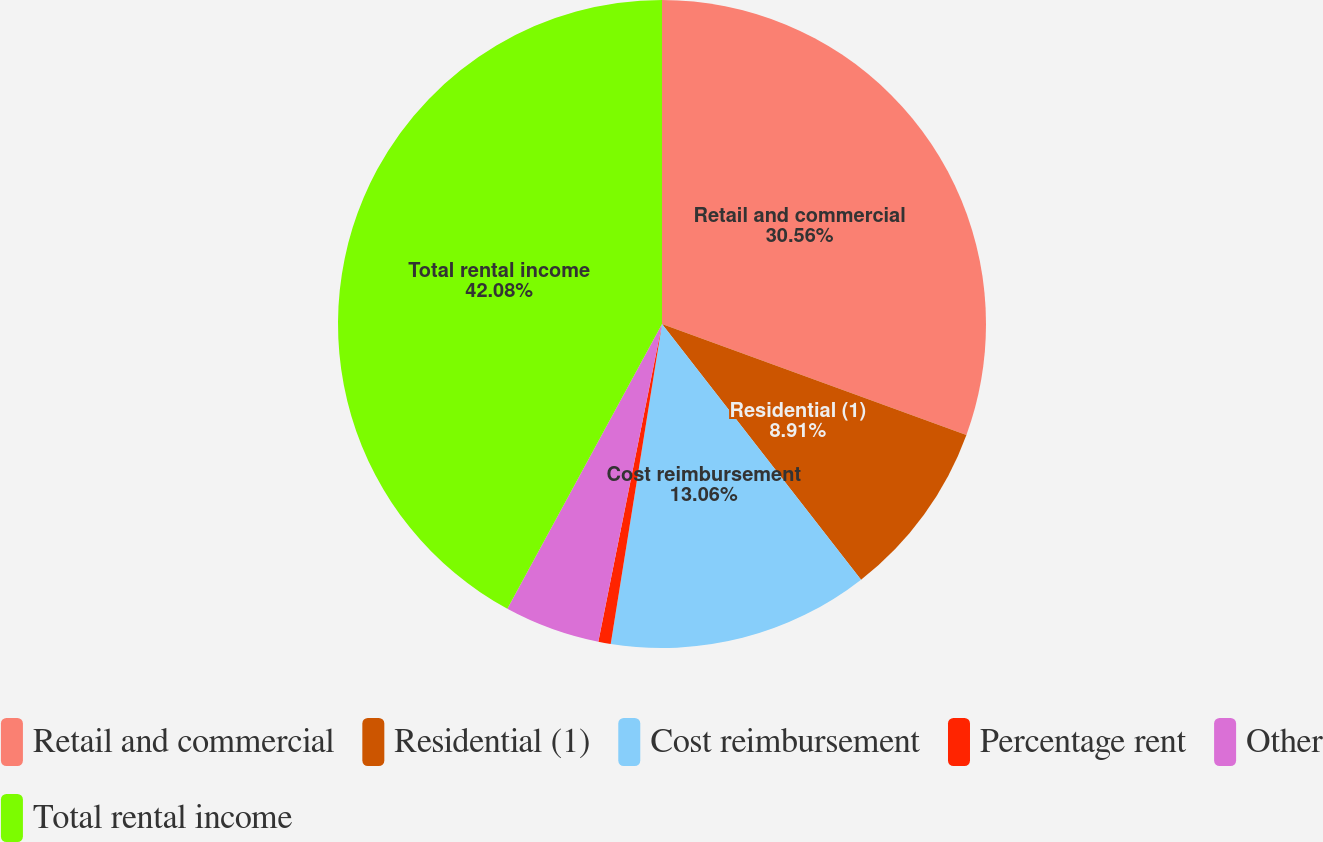Convert chart to OTSL. <chart><loc_0><loc_0><loc_500><loc_500><pie_chart><fcel>Retail and commercial<fcel>Residential (1)<fcel>Cost reimbursement<fcel>Percentage rent<fcel>Other<fcel>Total rental income<nl><fcel>30.56%<fcel>8.91%<fcel>13.06%<fcel>0.62%<fcel>4.77%<fcel>42.08%<nl></chart> 